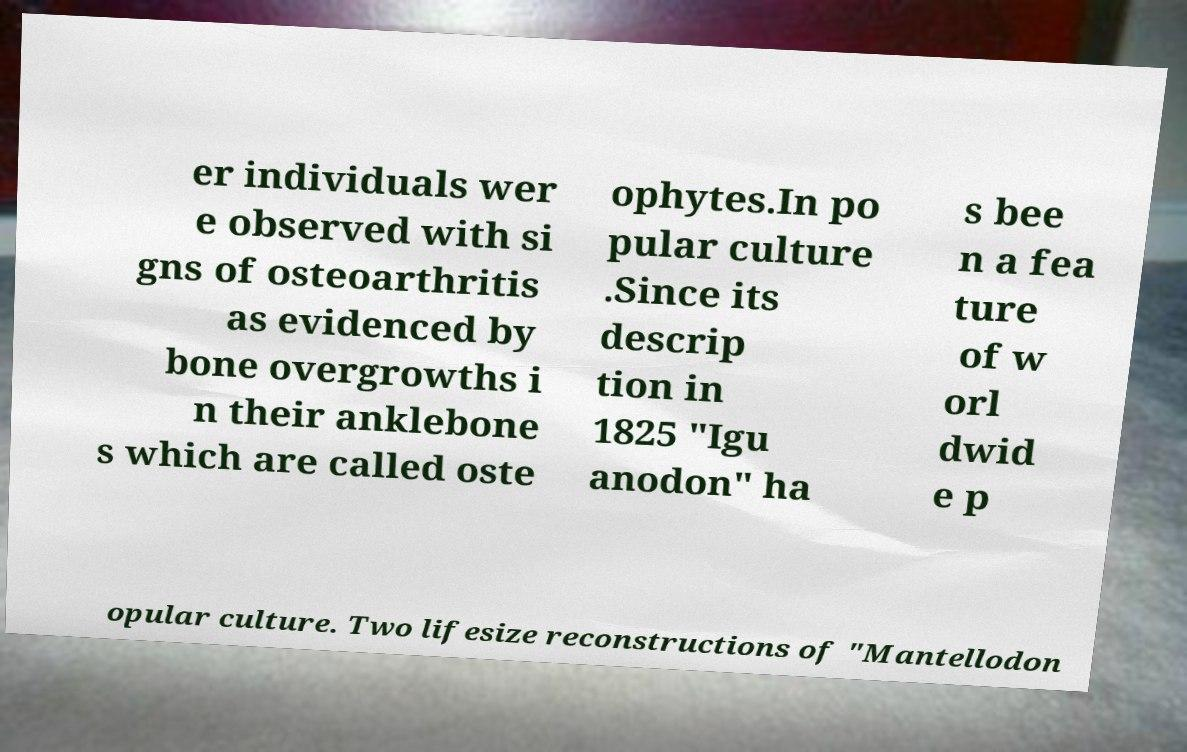Can you read and provide the text displayed in the image?This photo seems to have some interesting text. Can you extract and type it out for me? er individuals wer e observed with si gns of osteoarthritis as evidenced by bone overgrowths i n their anklebone s which are called oste ophytes.In po pular culture .Since its descrip tion in 1825 "Igu anodon" ha s bee n a fea ture of w orl dwid e p opular culture. Two lifesize reconstructions of "Mantellodon 